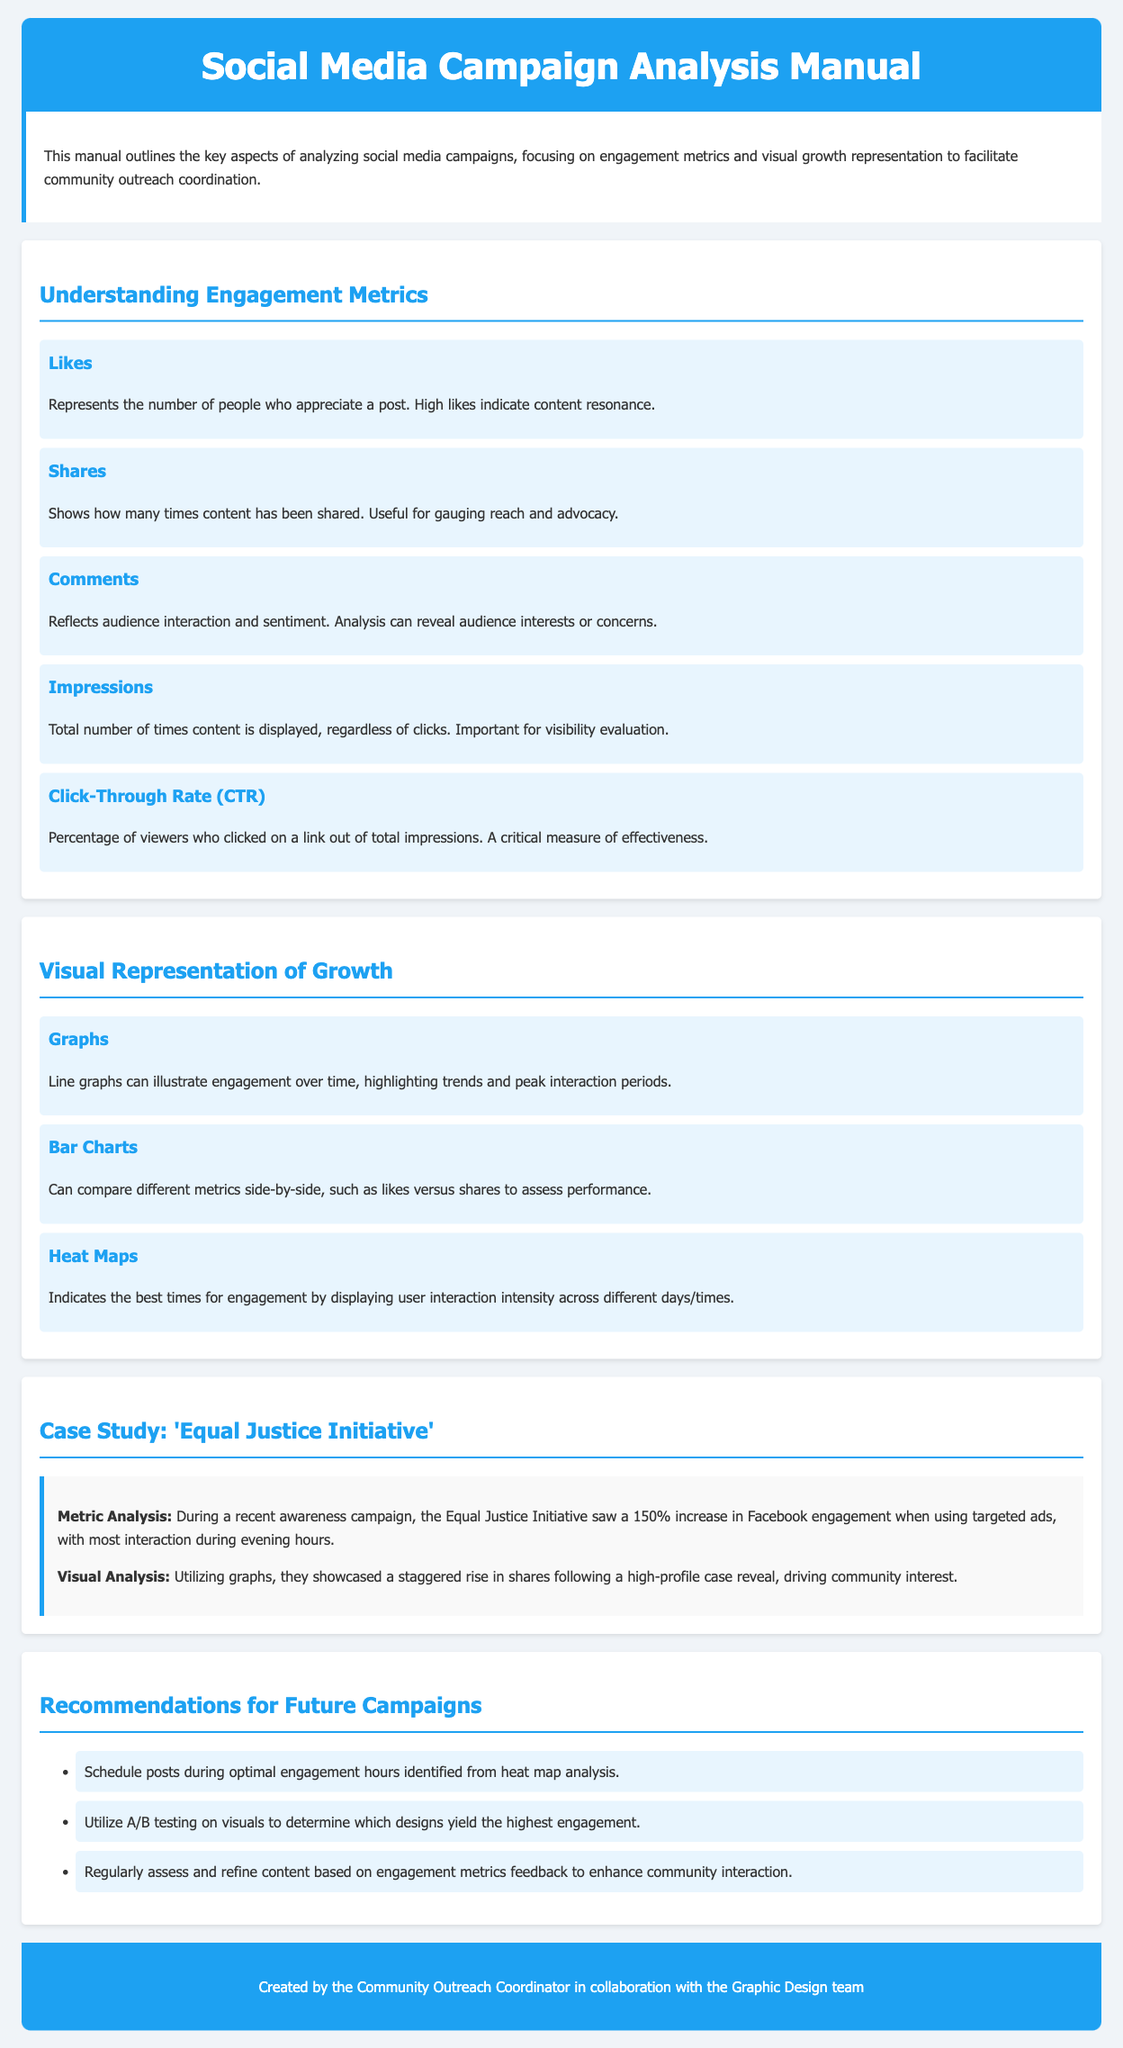What are the key engagement metrics described in the document? The document details several engagement metrics critical for analysis, including likes, shares, comments, impressions, and click-through rate.
Answer: Likes, Shares, Comments, Impressions, Click-Through Rate What does a high click-through rate indicate? A high click-through rate indicates effectiveness in driving viewers to click on links out of total impressions.
Answer: Effectiveness What type of graph is recommended for showing engagement over time? The document suggests using line graphs to illustrate engagement trends over time.
Answer: Line graphs Which organization is used as a case study in the manual? The manual includes a case study of the Equal Justice Initiative for analyzing engagement metrics.
Answer: Equal Justice Initiative What increase in engagement did the case study organization experience during their campaign? The Equal Justice Initiative saw a 150% increase in Facebook engagement during their campaign.
Answer: 150% What is one recommendation for future campaigns? One of the recommendations states to schedule posts during optimal engagement hours based on heat map analysis.
Answer: Schedule posts during optimal engagement hours What visual tool can indicate the best times for engagement? Heat maps are recommended to indicate the best times for audience engagement in the document.
Answer: Heat maps How does the document describe bar charts? Bar charts are described as tools that can compare different metrics side-by-side to assess performance.
Answer: Compare different metrics side-by-side 